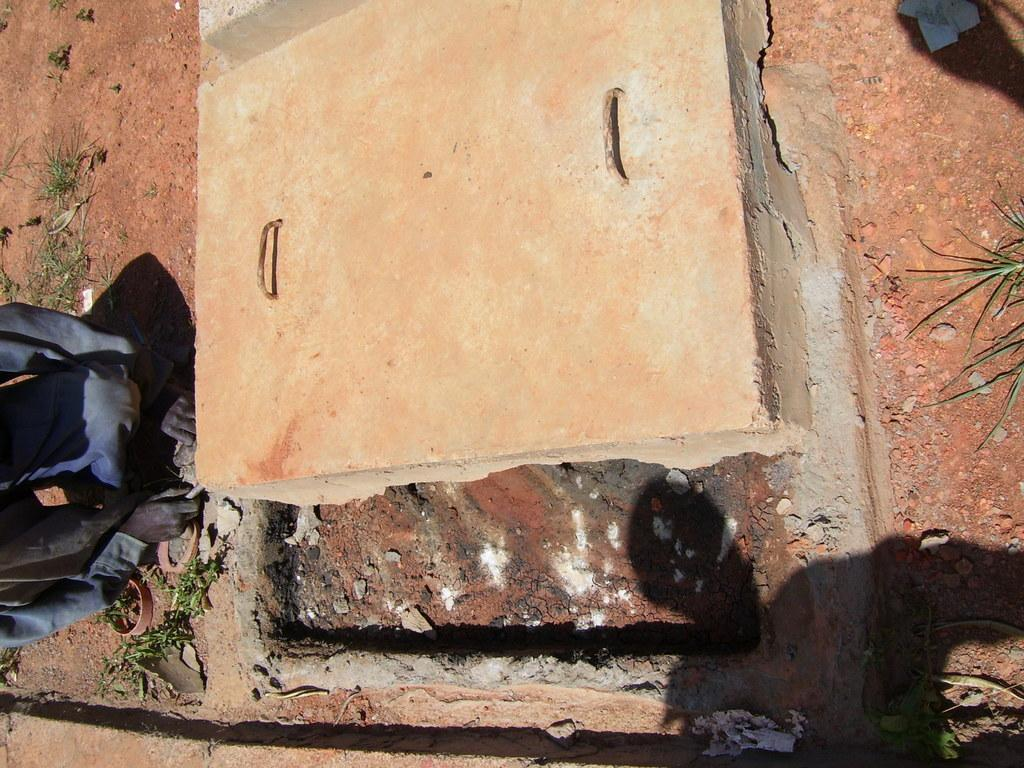Who is present in the image? There is a person in the image. What is the person's position in the image? The person is on the ground. What type of vegetation can be seen in the image? There is grass visible in the image. What type of structure is present in the image? There is a manhole with a lid in the image. What sign is the person attempting to transport in the image? There is no sign present in the image, and the person is not attempting to transport anything. 